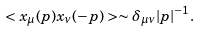Convert formula to latex. <formula><loc_0><loc_0><loc_500><loc_500>< x _ { \mu } ( p ) x _ { \nu } ( - p ) > \sim \delta _ { \mu \nu } | p | ^ { - 1 } .</formula> 